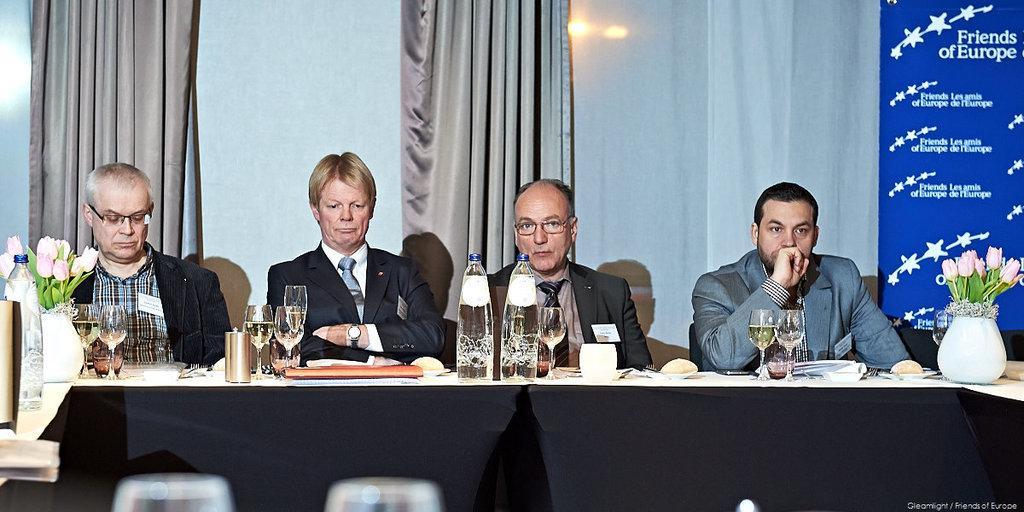Can you describe this image briefly? In this picture we can see four persons sitting on the chairs. This is the table. On the table there are glasses, bottles, file, and flower vase. On the background there is a wall. and this is the curtain. Here we can see a light. 